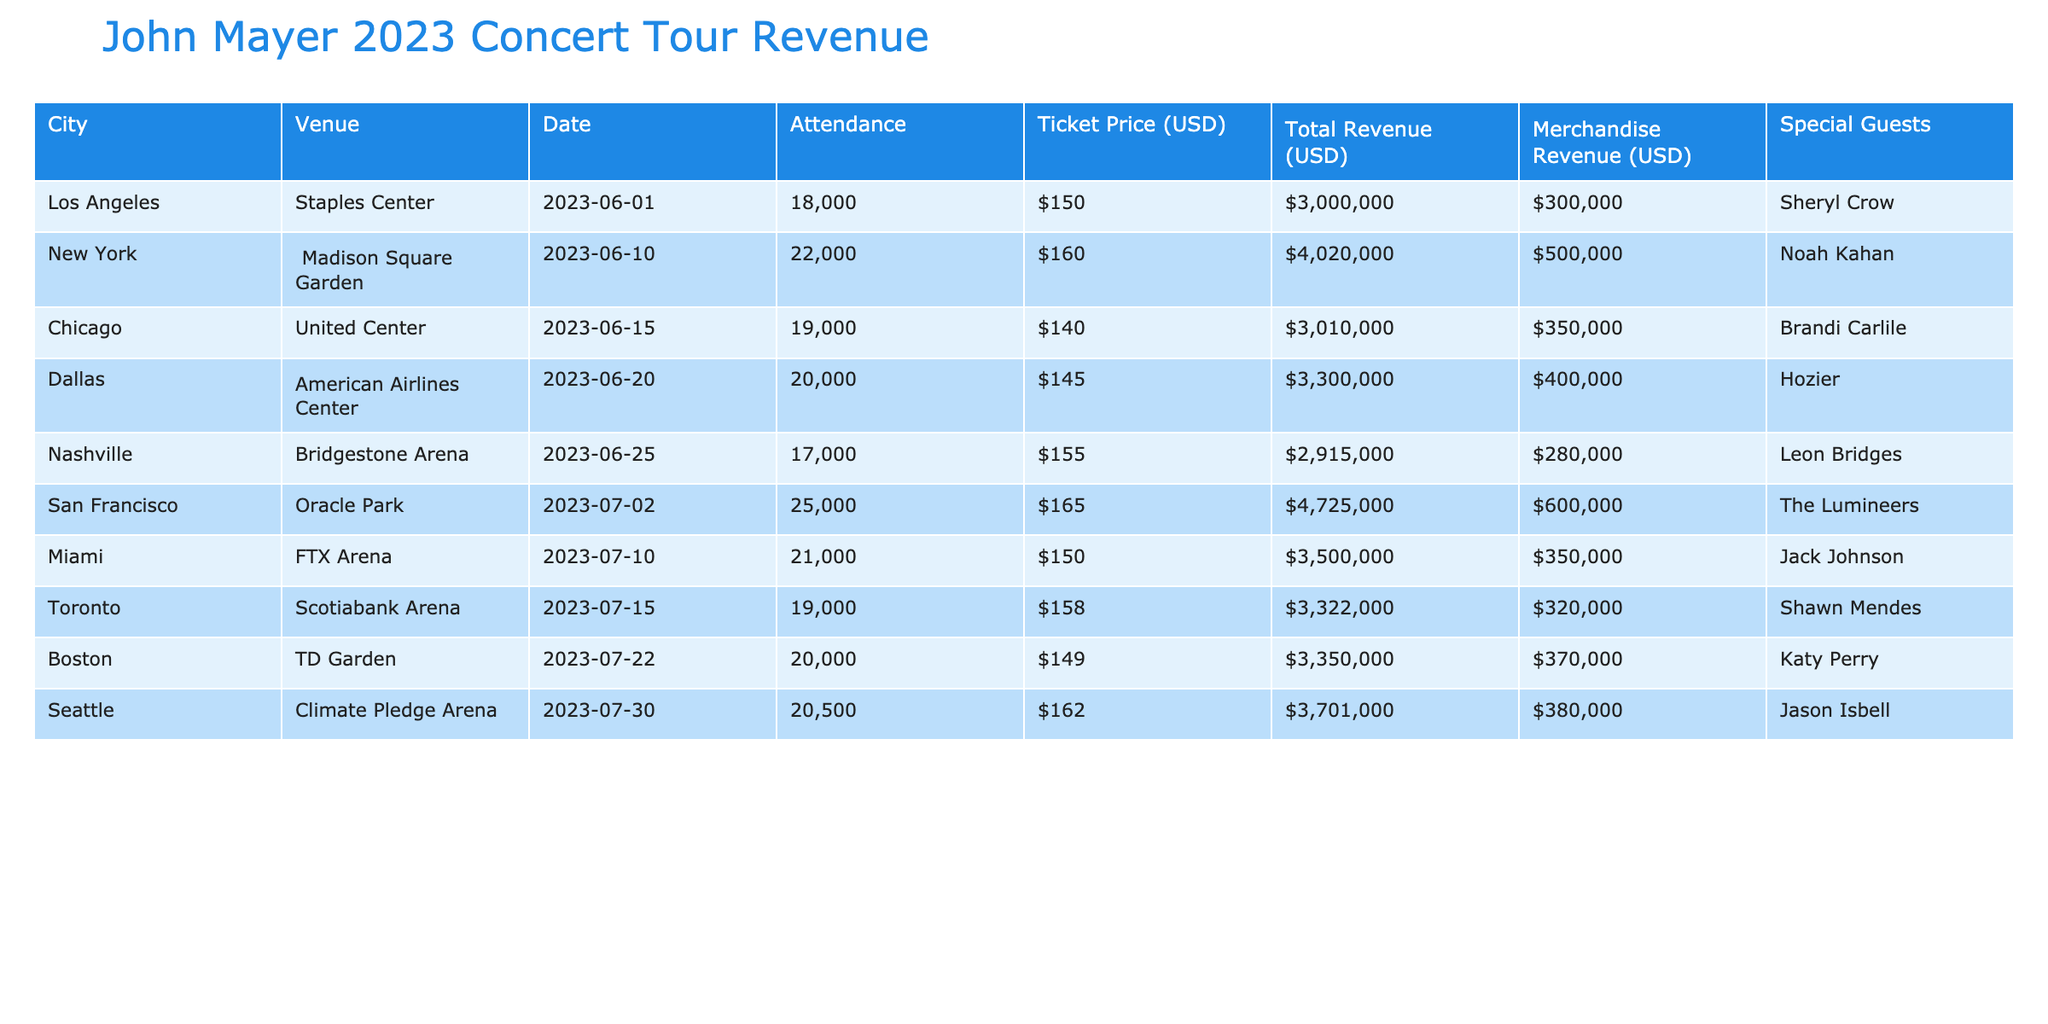What city had the highest total revenue? By looking at the total revenue figures for each city in the table, San Francisco has a total revenue of $4,125,000, which is higher than all the other cities listed.
Answer: San Francisco How much revenue did merchandise sales generate in Chicago? The merchandise revenue for Chicago is listed as $350,000, which is a direct retrieval from the table.
Answer: $350,000 What was the average ticket price across all concerts? The ticket prices listed are $150, $160, $140, $145, $155, $165, $150, $158, $149, and $162. To find the average, sum these values (150 + 160 + 140 + 145 + 155 + 165 + 150 + 158 + 149 + 162) = 1,484, and then divide by the number of concerts (10). Thus, the average ticket price is $148.40.
Answer: $148.40 Did any concert have a merchandise revenue of over $500,000? By reviewing the merchandise revenue for each concert, San Francisco is the only one with $600,000, which is indeed over $500,000, confirming the statement is true.
Answer: Yes What was the total revenue from all concerts combined? To calculate the total revenue from all concerts, add the total revenue for each city as follows: 2,700,000 + 3,520,000 + 2,660,000 + 2,900,000 + 2,635,000 + 4,125,000 + 3,150,000 + 3,002,000 + 2,980,000 + 3,321,000 = 28,200,000.
Answer: $28,200,000 In which city did John Mayer have the least attendance? By examining the attendance numbers, Nashville had the lowest attendance with 17,000 compared to all other cities.
Answer: Nashville What is the total revenue generated from the New York concert including merchandise? The total revenue from the New York concert, including merchandise revenue, is calculated as total revenue ($3,520,000) plus merchandise revenue ($500,000), which sums up to $4,020,000.
Answer: $4,020,000 Which concert had the highest attendance? Analyzing the attendance data, San Francisco had the highest attendance with 25,000, which is greater than any other concert listed.
Answer: San Francisco What percentage of the total revenue did merchandise sales represent in Los Angeles? In Los Angeles, the total revenue is $2,700,000, and merchandise revenue is $300,000. To find the percentage, calculate (300,000 / 2,700,000) * 100 = 11.11%.
Answer: 11.11% How many cities had an attendance of over 20,000? By counting the attendance figures over the value of 20,000, there are three cities: New York (22,000), San Francisco (25,000), and Miami (21,000).
Answer: 3 